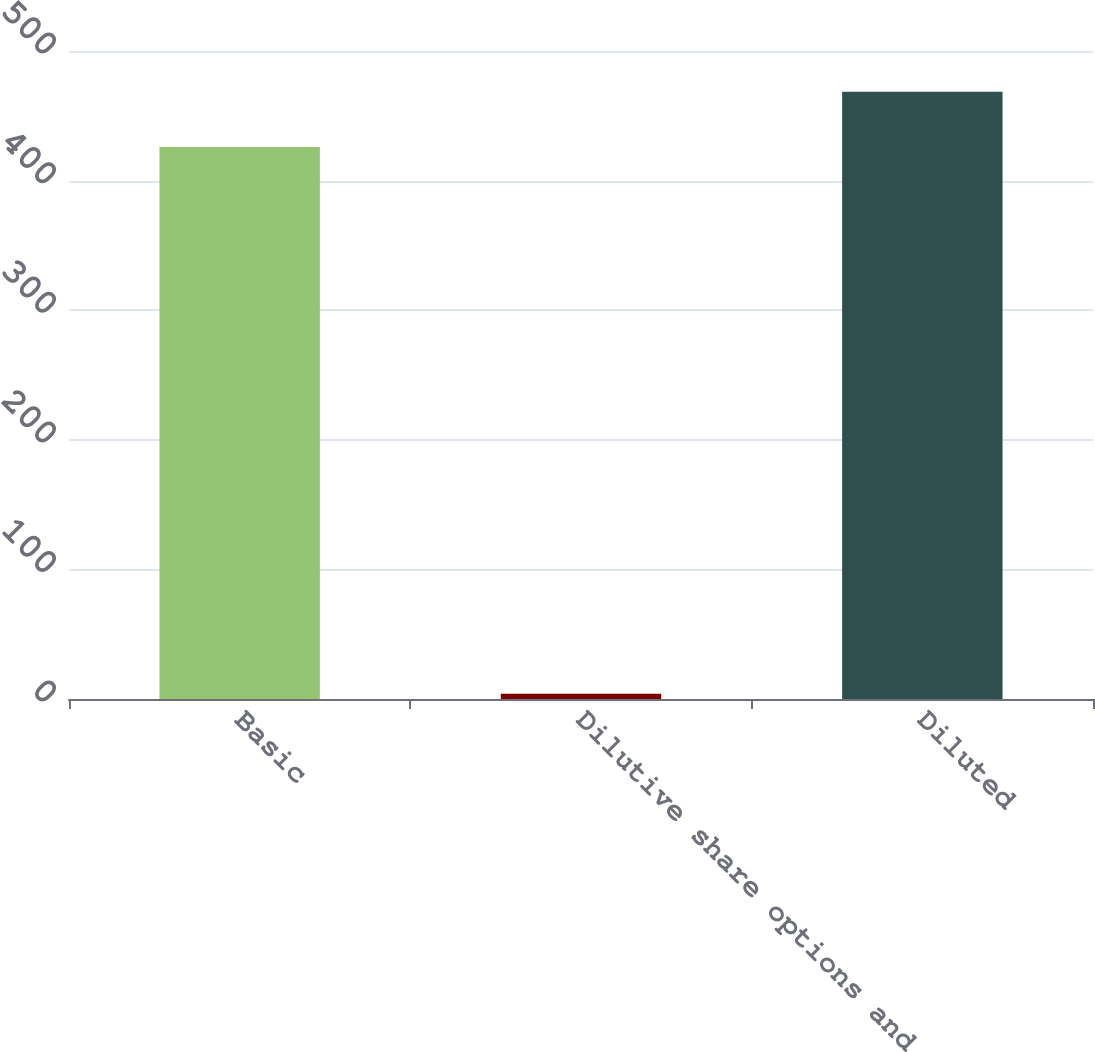Convert chart to OTSL. <chart><loc_0><loc_0><loc_500><loc_500><bar_chart><fcel>Basic<fcel>Dilutive share options and<fcel>Diluted<nl><fcel>426<fcel>4<fcel>468.6<nl></chart> 